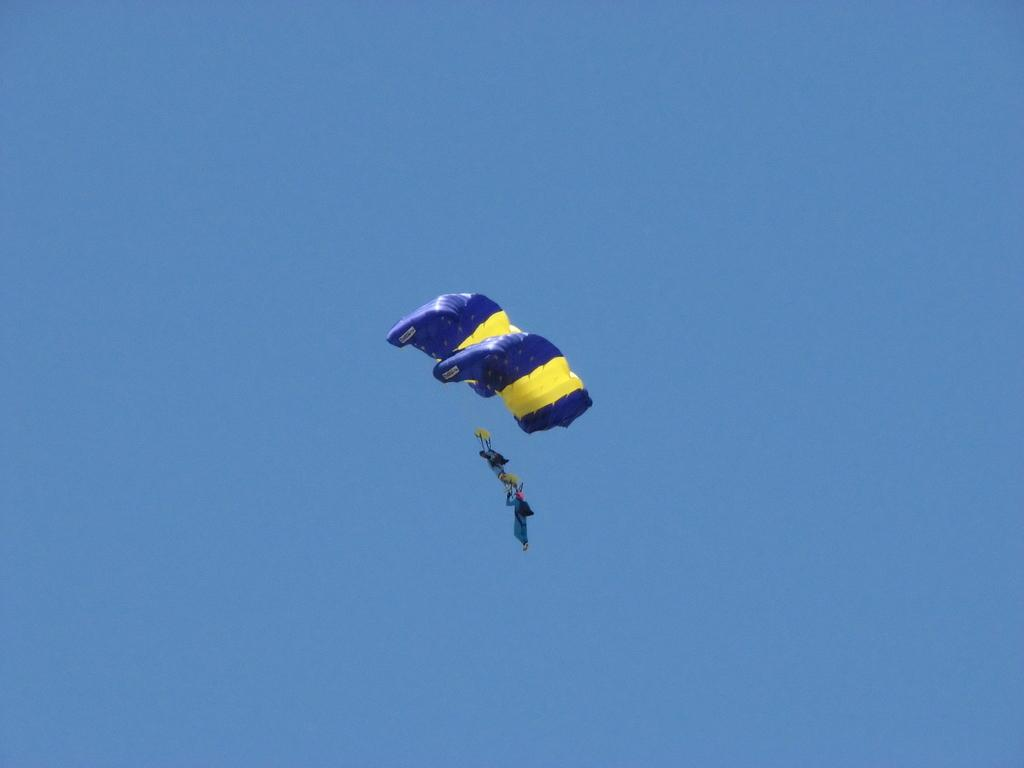Who or what is present in the image? There are people in the image. What are the people doing in the image? The people are flying in the air. How are the people flying in the air? The people are using parachutes. What type of oatmeal can be seen in the image? There is no oatmeal present in the image. What is the color of the brain in the image? There is no brain present in the image. 